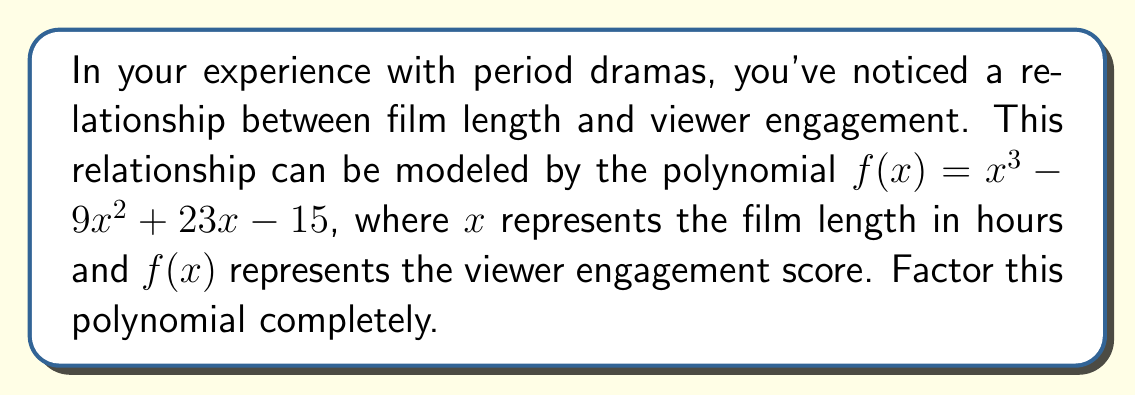Provide a solution to this math problem. Let's approach this step-by-step:

1) First, we should check if there are any rational roots. We can use the rational root theorem. The possible rational roots are the factors of the constant term (15): ±1, ±3, ±5, ±15.

2) Testing these values, we find that $f(1) = 0$. So $(x-1)$ is a factor.

3) We can use polynomial long division to divide $f(x)$ by $(x-1)$:

   $x^3 - 9x^2 + 23x - 15 = (x-1)(x^2 - 8x + 15)$

4) Now we need to factor the quadratic $x^2 - 8x + 15$. We can use the quadratic formula or factoring by grouping.

5) The quadratic factors as $(x-3)(x-5)$

Therefore, the complete factorization is:

$$f(x) = (x-1)(x-3)(x-5)$$

This factorization reveals that the viewer engagement score will be zero when the film length is 1 hour, 3 hours, or 5 hours, which could be interesting insights for a seasoned actor in period dramas.
Answer: $(x-1)(x-3)(x-5)$ 